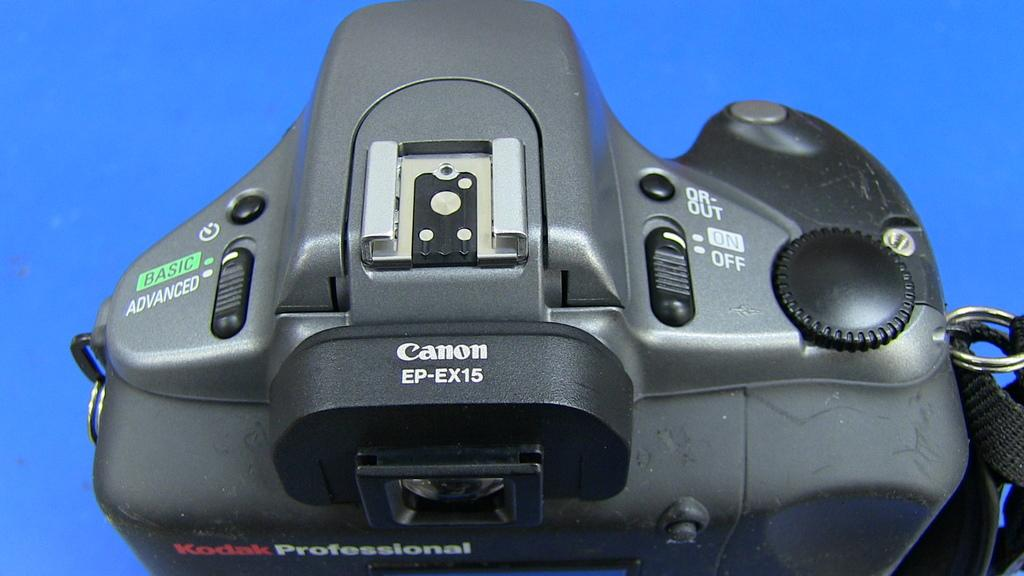<image>
Give a short and clear explanation of the subsequent image. a black canon camera that is labeled as 'kodak professional' 